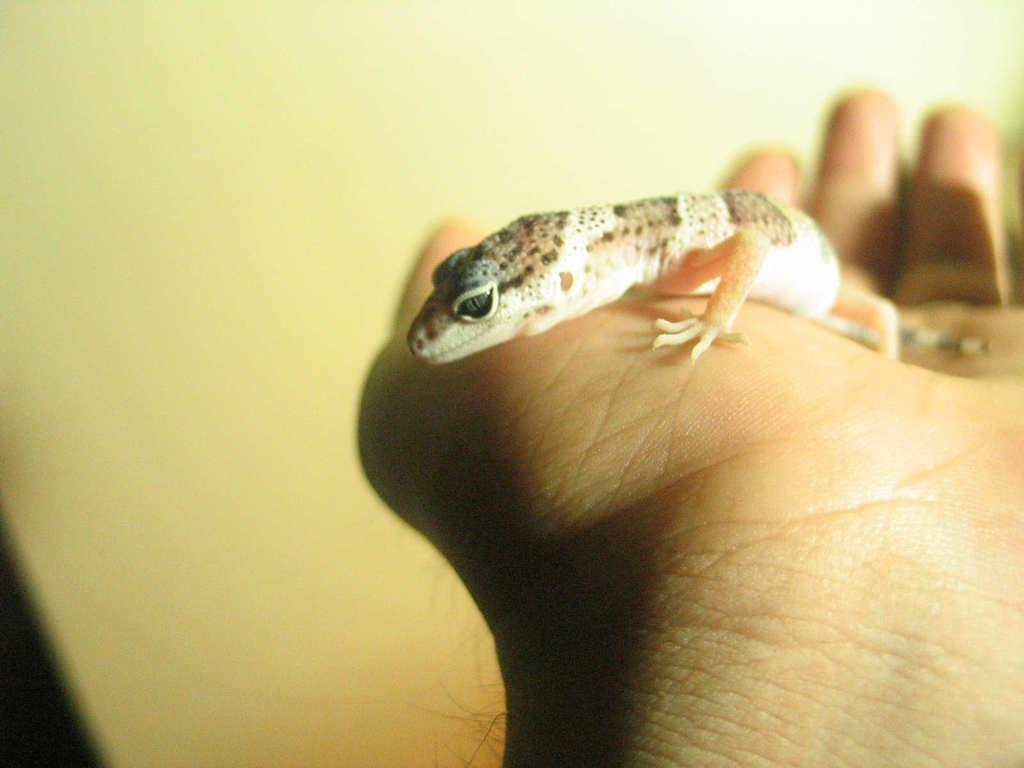What type of animal is in the image? There is a lizard in the image. Where is the lizard located? The lizard is in a human hand. What can be seen in the background of the image? There appears to be a wall in the background of the image. What type of cap is the son wearing in the image? There is no son or cap present in the image; it features a lizard in a human hand with a wall in the background. 